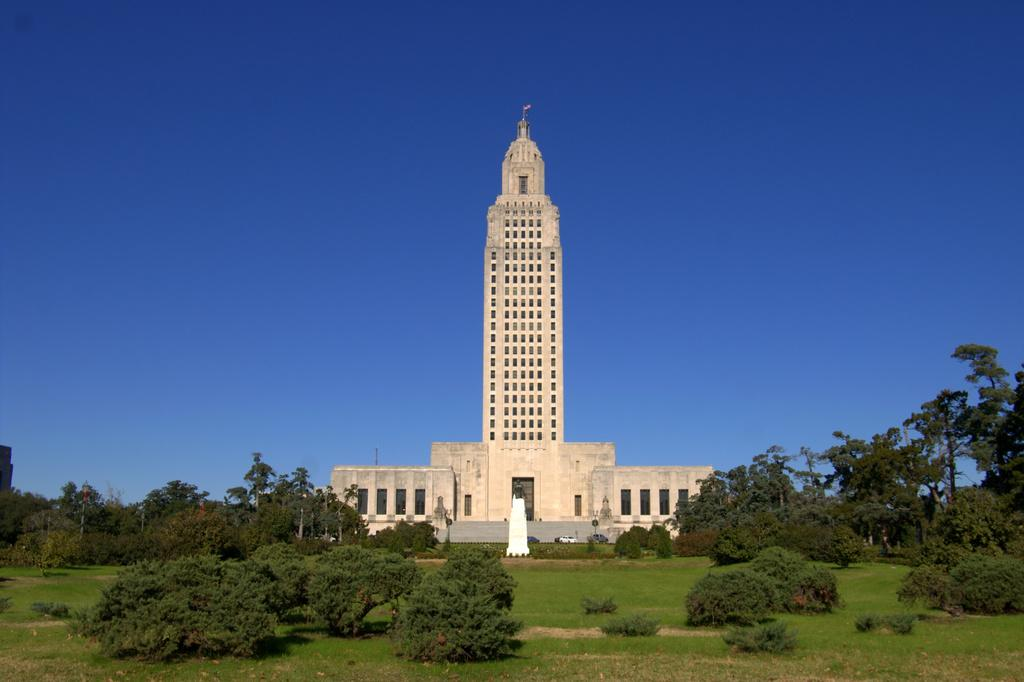What is the main structure in the center of the image? There is a building in the center of the image. What type of vegetation can be seen in the image? There are trees in the image. What type of ground is visible at the bottom of the image? There is grass at the bottom of the image. What can be seen in the background of the image? The sky is visible in the background of the image. How many yams are being used as a bookmark in the image? There are no yams or books present in the image. 